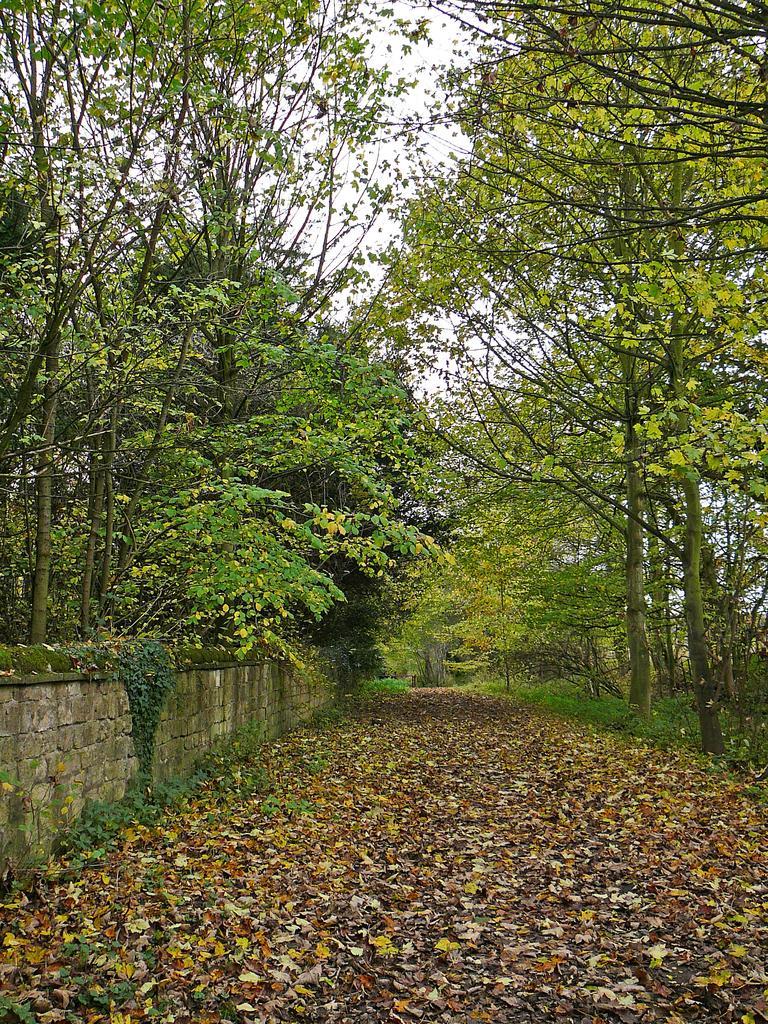Can you describe this image briefly? In this image I can see few trees, wall and few dry leaves on the ground. The sky is in white color. 